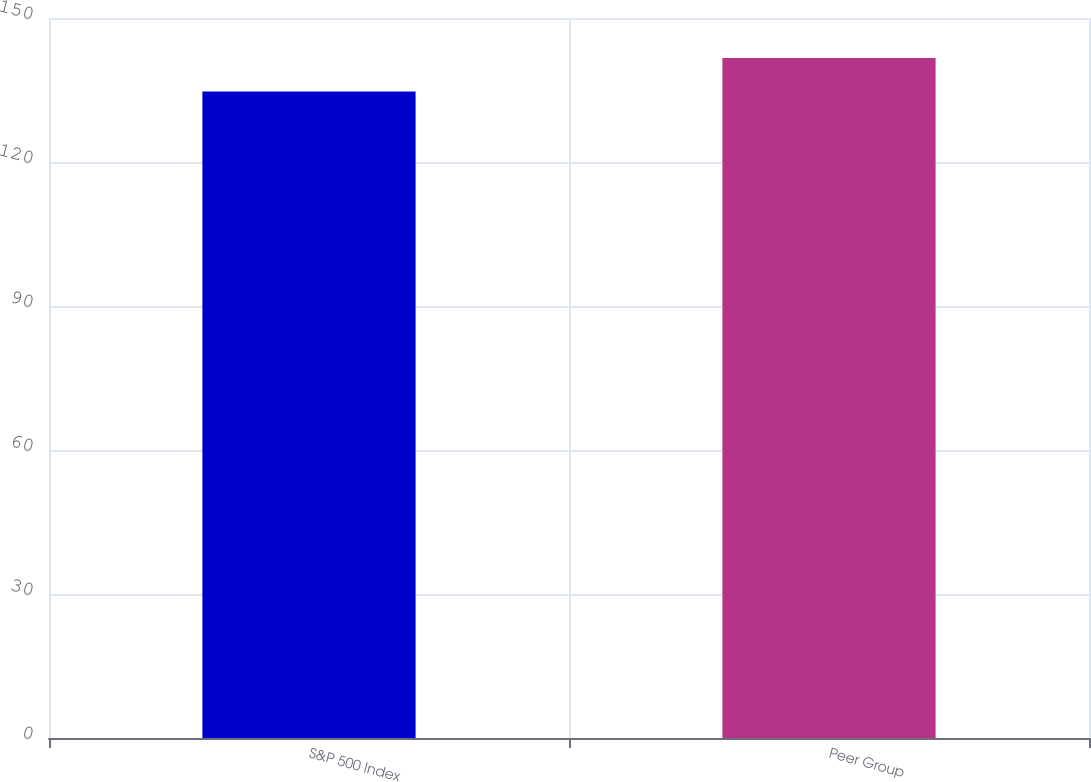<chart> <loc_0><loc_0><loc_500><loc_500><bar_chart><fcel>S&P 500 Index<fcel>Peer Group<nl><fcel>134.7<fcel>141.69<nl></chart> 